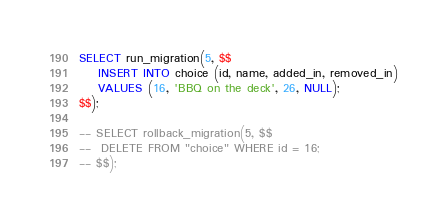<code> <loc_0><loc_0><loc_500><loc_500><_SQL_>SELECT run_migration(5, $$
	INSERT INTO choice (id, name, added_in, removed_in)
	VALUES (16, 'BBQ on the deck', 26, NULL);
$$);

-- SELECT rollback_migration(5, $$
-- 	DELETE FROM "choice" WHERE id = 16;
-- $$);</code> 